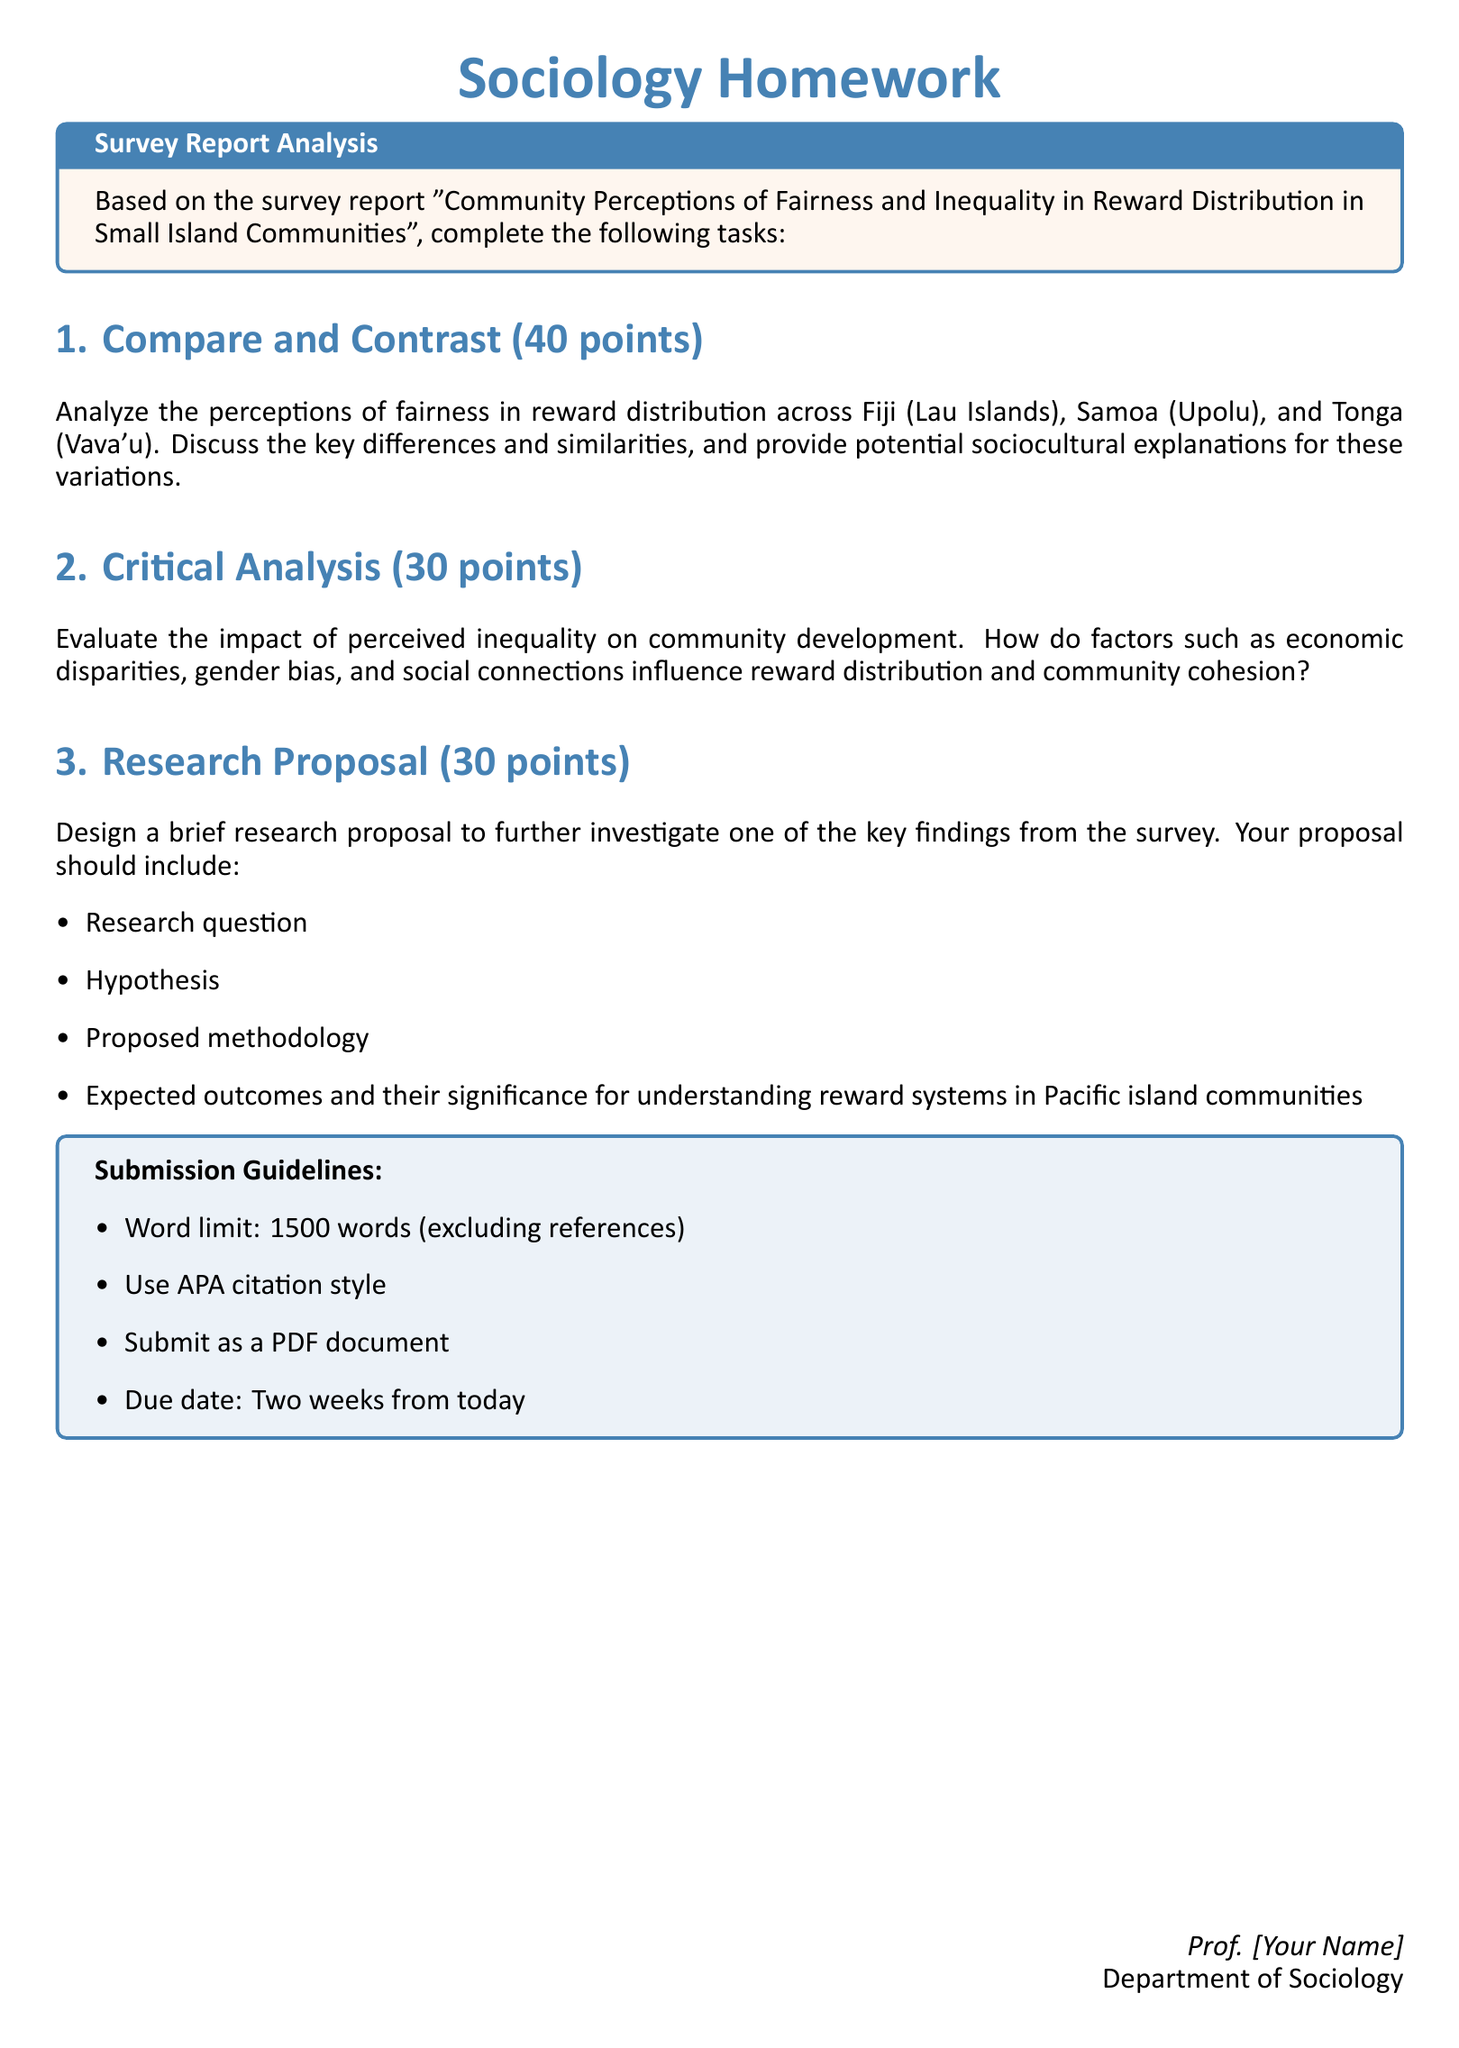what is the title of the homework? The title is specified at the top of the document and denotes the focus of the assignment.
Answer: Sociology Homework how many points is the 'Compare and Contrast' section worth? The document explicitly states the points associated with each section, including the 'Compare and Contrast' section.
Answer: 40 points what is the word limit for the submission? The word limit for the written assignment is highlighted in the submission guidelines section of the document.
Answer: 1500 words what is the due date for the assignment? The document indicates that the assignment is due two weeks from the date of distribution without providing a specific date.
Answer: Two weeks from today what is one key factor that should be evaluated in the 'Critical Analysis' section? The homework instructs students to evaluate various factors impacting reward distribution, including economic disparities, gender bias, and social connections in the context of community cohesion.
Answer: Economic disparities what type of citation style should be used in submissions? The document specifies a particular academic format required for referencing sources in the assignment.
Answer: APA citation style what is required in the research proposal? The document outlines specific elements that must be included in the research proposal as listed in the bullet points.
Answer: Research question which island communities are mentioned in the comparisons of fairness in reward distribution? The document explicitly names the islands involved in the comparison, linking them to their respective countries.
Answer: Lau Islands, Upolu, Vava'u what format should the submission be in? The guidelines state the required document format for submission as part of the instructions.
Answer: PDF document 